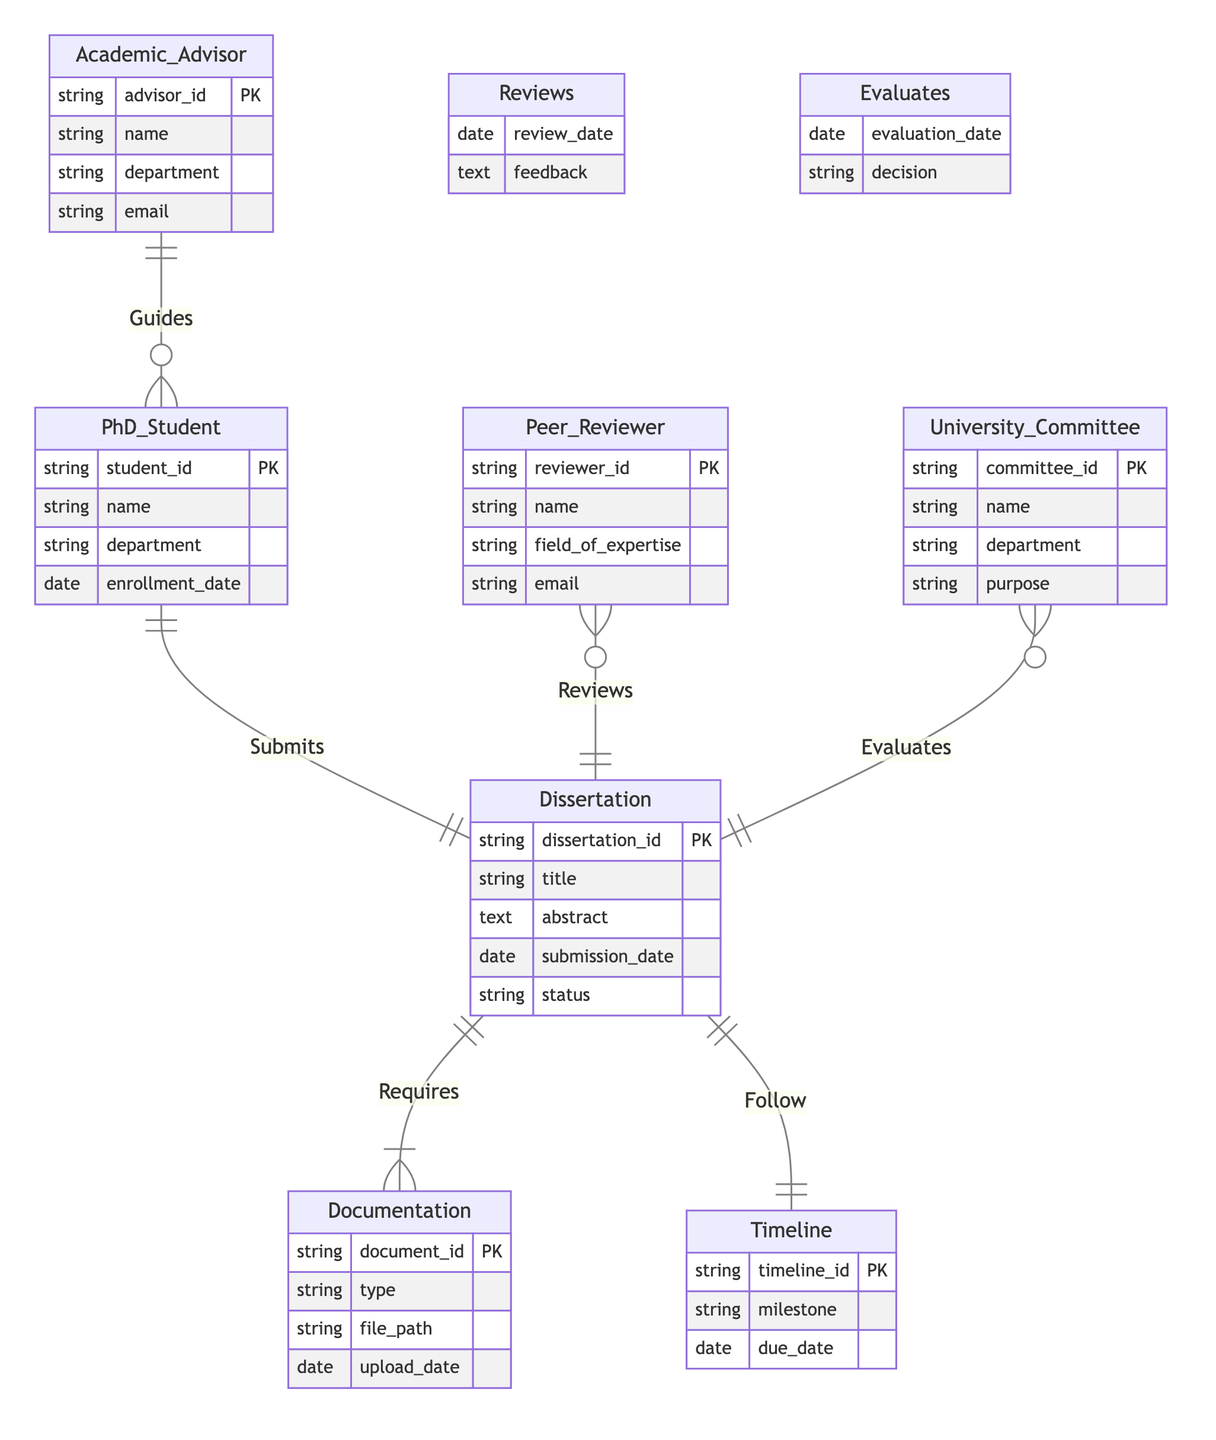What is the primary entity that submits the dissertation? In the diagram, the entity primarily responsible for submitting the dissertation is labeled "PhD_Student." This can be determined by observing the "Submits" relationship that connects the "PhD_Student" entity to the "Dissertation" entity.
Answer: PhD_Student How many entities are involved in the dissertation process? By counting the listed entities at the top of the diagram, there are seven different entities represented: PhD_Student, Dissertation, Academic_Advisor, Peer_Reviewer, University_Committee, Documentation, and Timeline.
Answer: Seven What relationship connects Academic Advisor and PhD Student? The relationship depicted between "Academic_Advisor" and "PhD_Student" is labeled "Guides." This is shown in the diagram as a line connecting the two entities with the label indicating the nature of their interaction.
Answer: Guides What type of documentation is required for the dissertation? The entity that represents the required documentation in the diagram is labeled "Documentation." Since it has a relationship with "Dissertation," it implies that various types of documents are needed for the dissertation process.
Answer: Documentation Which entity evaluates the dissertation? The entity responsible for evaluating the dissertation is "University_Committee." This is evident from the relationship "Evaluates," which links the "University_Committee" entity with the "Dissertation" entity, indicating its evaluative role in the process.
Answer: University_Committee What is one attribute of the Peer Reviewer entity? One of the attributes listed for the "Peer_Reviewer" entity is "field_of_expertise." This can be found under the attributes of the "Peer_Reviewer" entity in the diagram, which describes a characteristic of that entity.
Answer: field_of_expertise What does the relationship "Reviews" track in the diagram? The relationship "Reviews" records interactions between the "Peer_Reviewer" and the "Dissertation," specifically documenting details such as "review_date" and "feedback" that are key to the reviewing process.
Answer: review_date and feedback How does the dissertation follow the timeline? The relationship "Follow" indicates how the "Dissertation" entity aligns with the "Timeline" entity, implying that the dissertation milestones or due dates are tracked within the contextual framework provided by the timeline.
Answer: Follow 